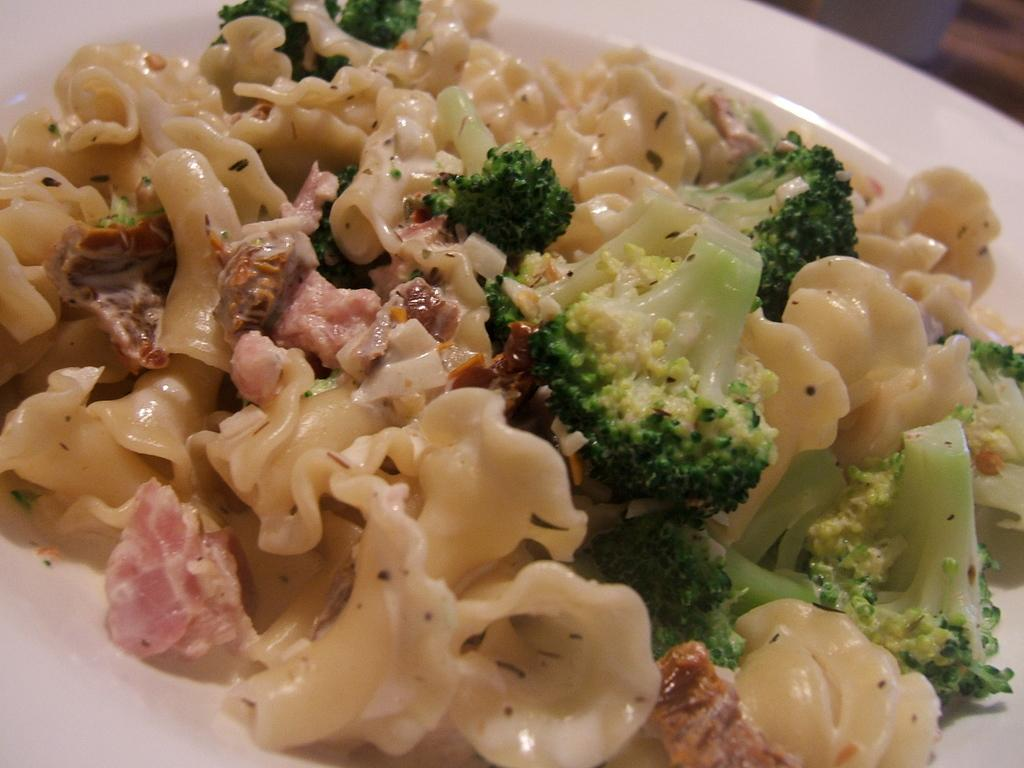What type of vegetable can be seen in the image? There is broccoli in the image. What is the main object on which the food is placed in the image? There is food on a plate in the image. How many times has the broccoli been folded in the image? The broccoli has not been folded in the image, as it is a vegetable and not a piece of fabric. 